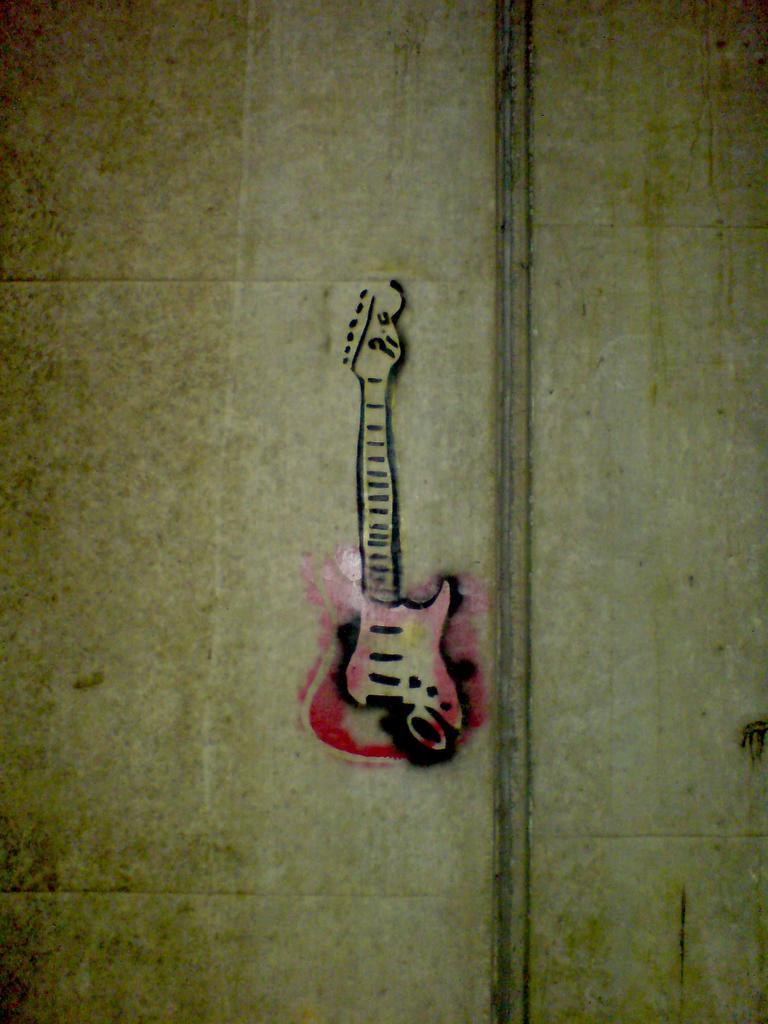In one or two sentences, can you explain what this image depicts? In the center of the image there is a wall. On the wall, we can see a painting of a guitar. 